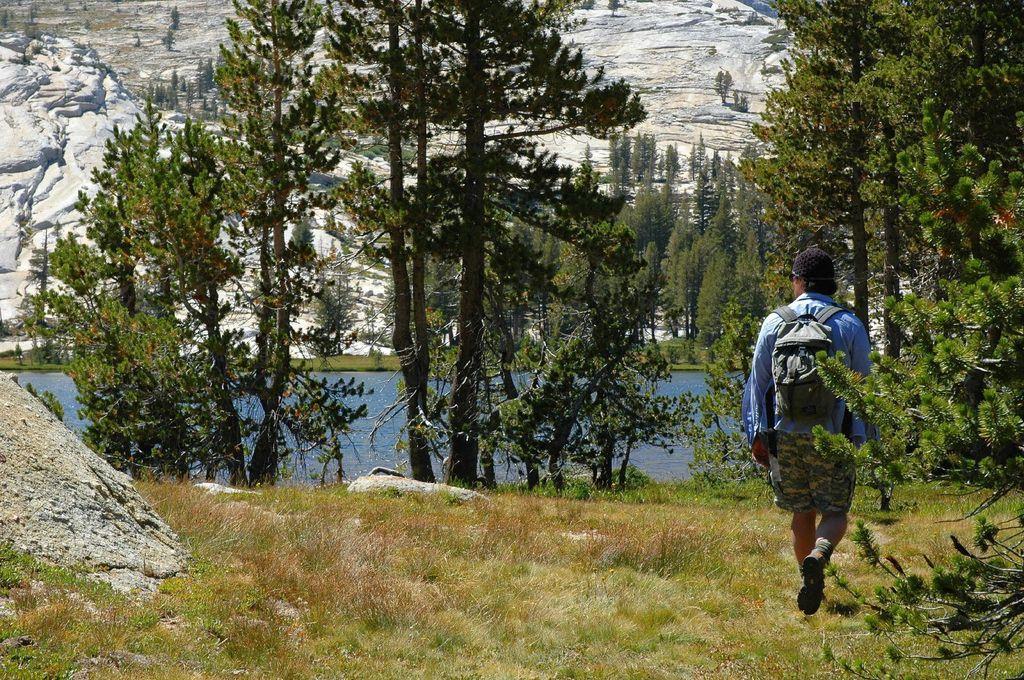Describe this image in one or two sentences. On the right side a man is walking, he wore shirt, short and a bag. In the middle there are trees and water. 